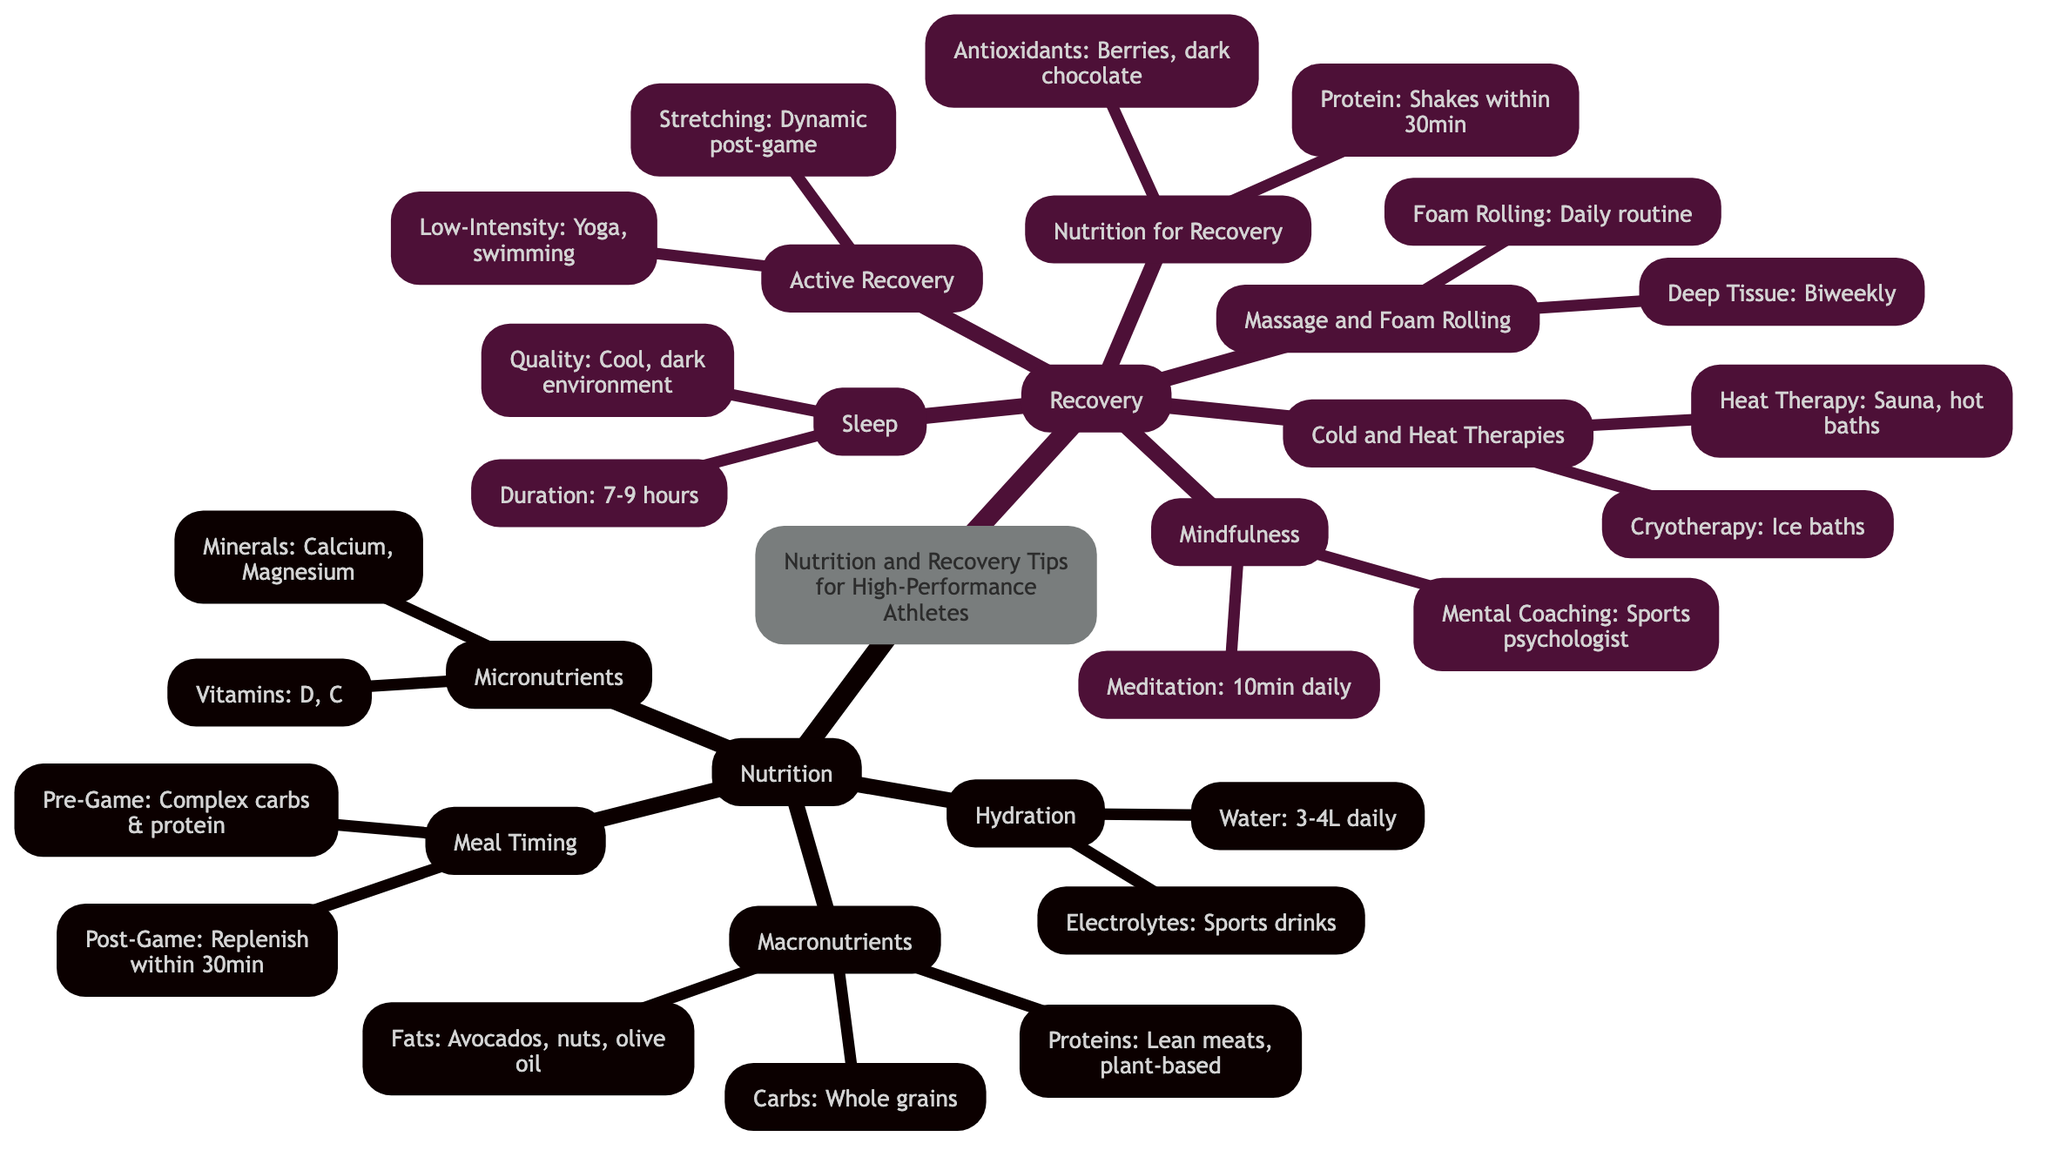What is the daily water intake recommended for athletes? The diagram specifies the recommended daily intake of water under the "Hydration" section, indicating it should be 3-4 liters.
Answer: 3-4 liters What is one source of protein mentioned in the macronutrients section? The macronutrients section lists lean meats such as chicken, turkey, fish, as well as plant-based sources like lentils and tofu under "Proteins." Any of these can be named as a source of protein.
Answer: Lean meats like chicken What combination of nutrients is suggested for pre-game meals? The meal timing section states that complex carbohydrates and protein should be consumed 2 hours before a game. This indicates the necessary nutrients for pre-game meals.
Answer: Complex carbs and protein How long should athletes sleep each night according to the recovery tips? The recovery section specifies in the "Sleep" area that athletes should aim for a duration of 7-9 hours per night.
Answer: 7-9 hours How often should athletes have deep tissue massages? The "Massage and Foam Rolling" category under recovery mentions that deep tissue massages should occur biweekly, indicating the frequency of these sessions.
Answer: Biweekly What type of therapy involves ice baths for recovery? The "Cold and Heat Therapies" section of the diagram labels ice baths as part of cryotherapy, identifying the specific therapy method used for recovery.
Answer: Cryotherapy Which vitamins are recommended for athletes according to micronutrients? The micronutrients section of the diagram lists Vitamin D and Vitamin C, which are both necessary for athletes as indicated under the "Vitamins" category.
Answer: Vitamin D and C What is the purpose of low-intensity workouts during active recovery? The "Active Recovery" section mentions practices like yoga and swimming, indicating their purpose as exercises on rest days to promote recovery while maintaining some physical activity.
Answer: Recovery on rest days What should be consumed within 30 minutes post-game? Under "Nutrition for Recovery," it states that shakes, either whey or plant-based, should be consumed within 30 minutes after workouts, specifying the timing for recovery nutrition.
Answer: Shakes within 30 minutes 